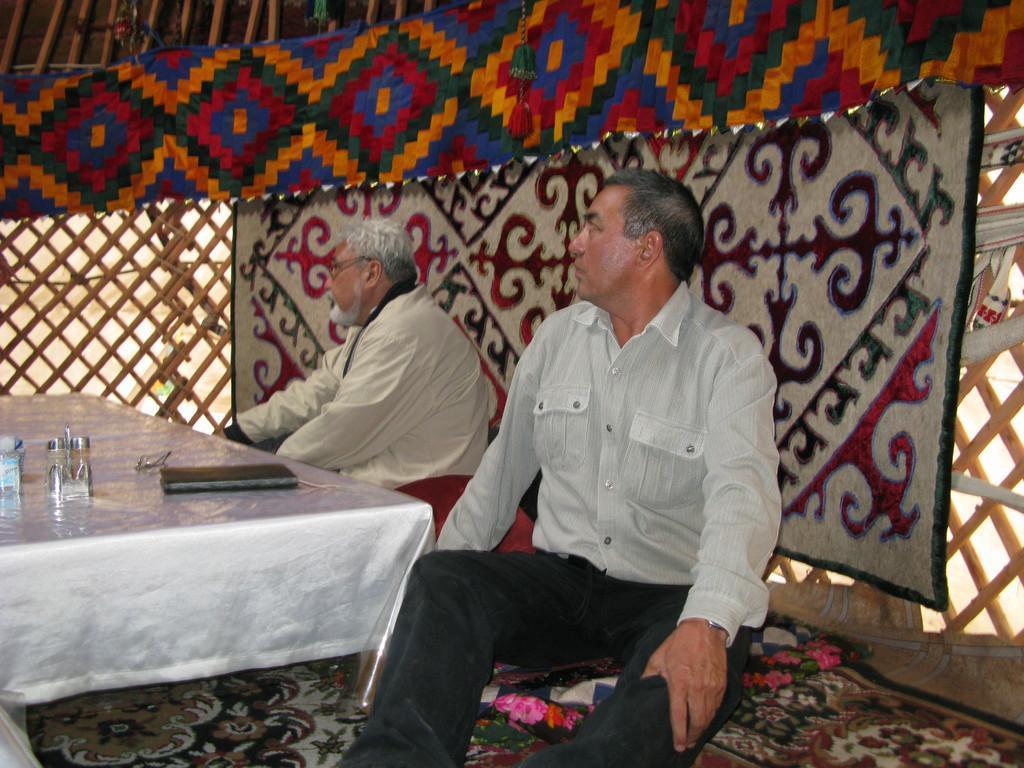How would you summarize this image in a sentence or two? Here we can see two persons are sitting on the chairs. This is table. On the table there is a cloth, bottles, and spectacles. This is floor. In the background there is a cloth and this is fence. 